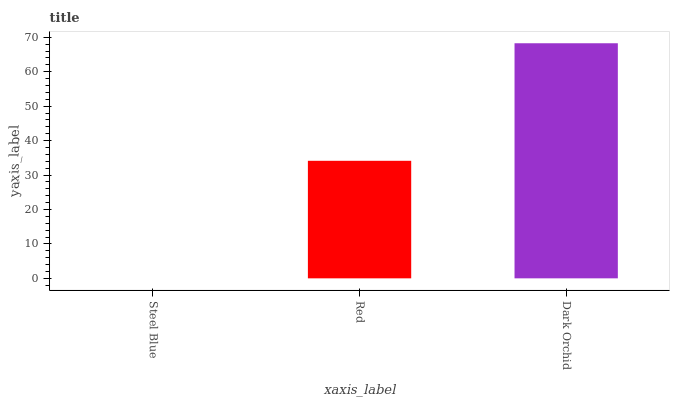Is Steel Blue the minimum?
Answer yes or no. Yes. Is Dark Orchid the maximum?
Answer yes or no. Yes. Is Red the minimum?
Answer yes or no. No. Is Red the maximum?
Answer yes or no. No. Is Red greater than Steel Blue?
Answer yes or no. Yes. Is Steel Blue less than Red?
Answer yes or no. Yes. Is Steel Blue greater than Red?
Answer yes or no. No. Is Red less than Steel Blue?
Answer yes or no. No. Is Red the high median?
Answer yes or no. Yes. Is Red the low median?
Answer yes or no. Yes. Is Dark Orchid the high median?
Answer yes or no. No. Is Steel Blue the low median?
Answer yes or no. No. 